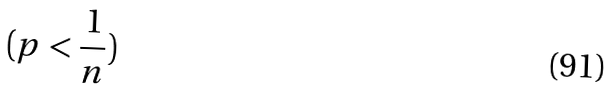<formula> <loc_0><loc_0><loc_500><loc_500>( p < \frac { 1 } { n } )</formula> 